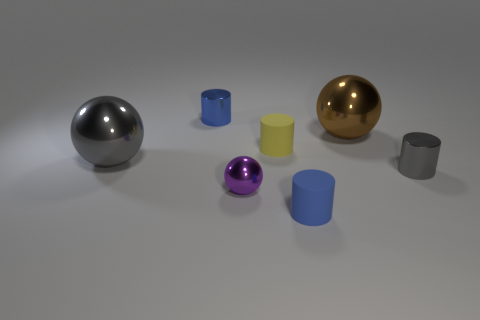Is there a purple thing? Yes, there is a small, shiny purple sphere on the left side, creating a vivid contrast with the other objects around it. 